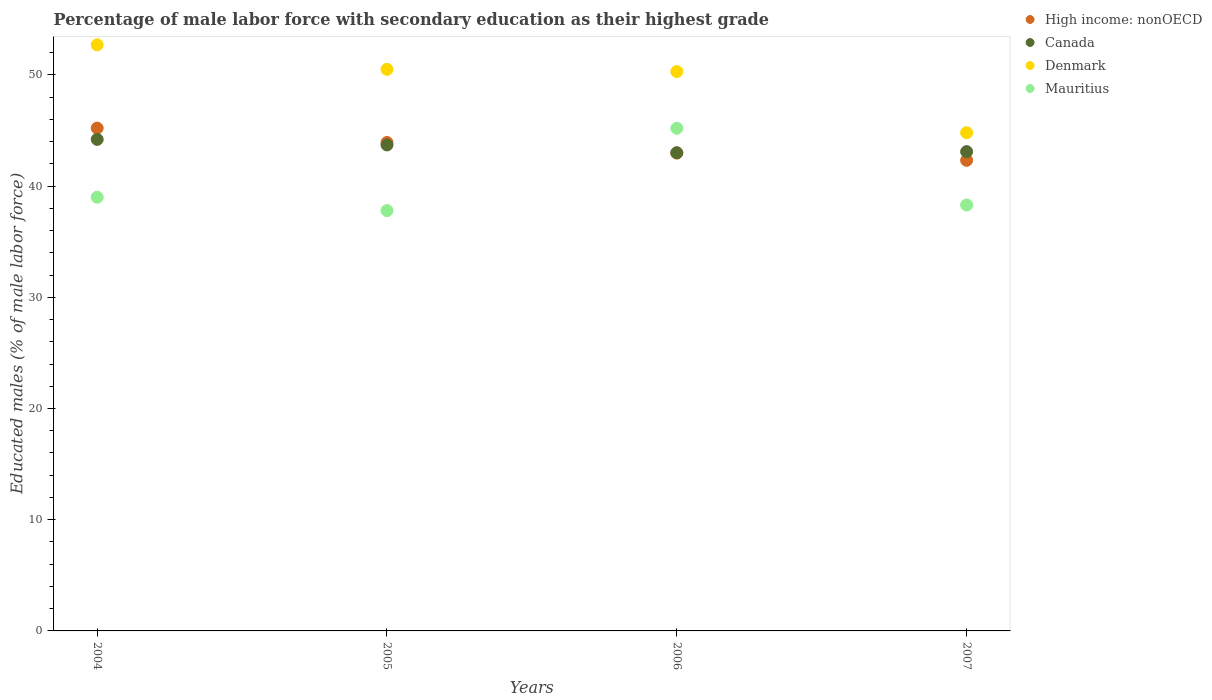Is the number of dotlines equal to the number of legend labels?
Offer a very short reply. Yes. What is the percentage of male labor force with secondary education in Denmark in 2007?
Your answer should be compact. 44.8. Across all years, what is the maximum percentage of male labor force with secondary education in High income: nonOECD?
Give a very brief answer. 45.21. Across all years, what is the minimum percentage of male labor force with secondary education in Canada?
Offer a very short reply. 43. In which year was the percentage of male labor force with secondary education in Canada maximum?
Give a very brief answer. 2004. In which year was the percentage of male labor force with secondary education in Canada minimum?
Give a very brief answer. 2006. What is the total percentage of male labor force with secondary education in Canada in the graph?
Your response must be concise. 174. What is the difference between the percentage of male labor force with secondary education in High income: nonOECD in 2004 and that in 2005?
Keep it short and to the point. 1.29. What is the difference between the percentage of male labor force with secondary education in Mauritius in 2006 and the percentage of male labor force with secondary education in High income: nonOECD in 2005?
Give a very brief answer. 1.28. What is the average percentage of male labor force with secondary education in Mauritius per year?
Make the answer very short. 40.07. In the year 2005, what is the difference between the percentage of male labor force with secondary education in High income: nonOECD and percentage of male labor force with secondary education in Mauritius?
Give a very brief answer. 6.12. What is the ratio of the percentage of male labor force with secondary education in Denmark in 2006 to that in 2007?
Provide a short and direct response. 1.12. Is the percentage of male labor force with secondary education in Canada in 2004 less than that in 2007?
Offer a terse response. No. What is the difference between the highest and the lowest percentage of male labor force with secondary education in Denmark?
Make the answer very short. 7.9. Is it the case that in every year, the sum of the percentage of male labor force with secondary education in Mauritius and percentage of male labor force with secondary education in Canada  is greater than the sum of percentage of male labor force with secondary education in High income: nonOECD and percentage of male labor force with secondary education in Denmark?
Your response must be concise. Yes. Is the percentage of male labor force with secondary education in Canada strictly greater than the percentage of male labor force with secondary education in High income: nonOECD over the years?
Ensure brevity in your answer.  No. What is the difference between two consecutive major ticks on the Y-axis?
Offer a terse response. 10. Does the graph contain grids?
Give a very brief answer. No. How many legend labels are there?
Give a very brief answer. 4. What is the title of the graph?
Make the answer very short. Percentage of male labor force with secondary education as their highest grade. What is the label or title of the X-axis?
Keep it short and to the point. Years. What is the label or title of the Y-axis?
Offer a terse response. Educated males (% of male labor force). What is the Educated males (% of male labor force) of High income: nonOECD in 2004?
Your answer should be compact. 45.21. What is the Educated males (% of male labor force) in Canada in 2004?
Your answer should be very brief. 44.2. What is the Educated males (% of male labor force) in Denmark in 2004?
Your answer should be compact. 52.7. What is the Educated males (% of male labor force) in Mauritius in 2004?
Provide a succinct answer. 39. What is the Educated males (% of male labor force) in High income: nonOECD in 2005?
Keep it short and to the point. 43.92. What is the Educated males (% of male labor force) of Canada in 2005?
Provide a succinct answer. 43.7. What is the Educated males (% of male labor force) in Denmark in 2005?
Offer a terse response. 50.5. What is the Educated males (% of male labor force) in Mauritius in 2005?
Your answer should be very brief. 37.8. What is the Educated males (% of male labor force) of High income: nonOECD in 2006?
Ensure brevity in your answer.  42.97. What is the Educated males (% of male labor force) in Canada in 2006?
Ensure brevity in your answer.  43. What is the Educated males (% of male labor force) in Denmark in 2006?
Make the answer very short. 50.3. What is the Educated males (% of male labor force) of Mauritius in 2006?
Give a very brief answer. 45.2. What is the Educated males (% of male labor force) of High income: nonOECD in 2007?
Offer a very short reply. 42.32. What is the Educated males (% of male labor force) of Canada in 2007?
Your response must be concise. 43.1. What is the Educated males (% of male labor force) of Denmark in 2007?
Your response must be concise. 44.8. What is the Educated males (% of male labor force) in Mauritius in 2007?
Keep it short and to the point. 38.3. Across all years, what is the maximum Educated males (% of male labor force) in High income: nonOECD?
Provide a succinct answer. 45.21. Across all years, what is the maximum Educated males (% of male labor force) in Canada?
Offer a very short reply. 44.2. Across all years, what is the maximum Educated males (% of male labor force) of Denmark?
Provide a succinct answer. 52.7. Across all years, what is the maximum Educated males (% of male labor force) in Mauritius?
Offer a terse response. 45.2. Across all years, what is the minimum Educated males (% of male labor force) of High income: nonOECD?
Make the answer very short. 42.32. Across all years, what is the minimum Educated males (% of male labor force) in Denmark?
Provide a succinct answer. 44.8. Across all years, what is the minimum Educated males (% of male labor force) in Mauritius?
Offer a very short reply. 37.8. What is the total Educated males (% of male labor force) of High income: nonOECD in the graph?
Your response must be concise. 174.42. What is the total Educated males (% of male labor force) in Canada in the graph?
Provide a short and direct response. 174. What is the total Educated males (% of male labor force) of Denmark in the graph?
Provide a short and direct response. 198.3. What is the total Educated males (% of male labor force) of Mauritius in the graph?
Provide a short and direct response. 160.3. What is the difference between the Educated males (% of male labor force) in High income: nonOECD in 2004 and that in 2005?
Provide a succinct answer. 1.29. What is the difference between the Educated males (% of male labor force) of Denmark in 2004 and that in 2005?
Your answer should be compact. 2.2. What is the difference between the Educated males (% of male labor force) of High income: nonOECD in 2004 and that in 2006?
Offer a very short reply. 2.24. What is the difference between the Educated males (% of male labor force) of Canada in 2004 and that in 2006?
Keep it short and to the point. 1.2. What is the difference between the Educated males (% of male labor force) of Denmark in 2004 and that in 2006?
Your response must be concise. 2.4. What is the difference between the Educated males (% of male labor force) of High income: nonOECD in 2004 and that in 2007?
Provide a short and direct response. 2.9. What is the difference between the Educated males (% of male labor force) in Canada in 2004 and that in 2007?
Give a very brief answer. 1.1. What is the difference between the Educated males (% of male labor force) in Denmark in 2004 and that in 2007?
Offer a very short reply. 7.9. What is the difference between the Educated males (% of male labor force) in Mauritius in 2004 and that in 2007?
Give a very brief answer. 0.7. What is the difference between the Educated males (% of male labor force) of High income: nonOECD in 2005 and that in 2006?
Ensure brevity in your answer.  0.95. What is the difference between the Educated males (% of male labor force) in Canada in 2005 and that in 2006?
Keep it short and to the point. 0.7. What is the difference between the Educated males (% of male labor force) of Denmark in 2005 and that in 2006?
Provide a short and direct response. 0.2. What is the difference between the Educated males (% of male labor force) of High income: nonOECD in 2005 and that in 2007?
Your response must be concise. 1.6. What is the difference between the Educated males (% of male labor force) in Canada in 2005 and that in 2007?
Provide a succinct answer. 0.6. What is the difference between the Educated males (% of male labor force) of Denmark in 2005 and that in 2007?
Give a very brief answer. 5.7. What is the difference between the Educated males (% of male labor force) of Mauritius in 2005 and that in 2007?
Keep it short and to the point. -0.5. What is the difference between the Educated males (% of male labor force) in High income: nonOECD in 2006 and that in 2007?
Your answer should be compact. 0.65. What is the difference between the Educated males (% of male labor force) in Mauritius in 2006 and that in 2007?
Make the answer very short. 6.9. What is the difference between the Educated males (% of male labor force) of High income: nonOECD in 2004 and the Educated males (% of male labor force) of Canada in 2005?
Provide a succinct answer. 1.51. What is the difference between the Educated males (% of male labor force) in High income: nonOECD in 2004 and the Educated males (% of male labor force) in Denmark in 2005?
Your answer should be very brief. -5.29. What is the difference between the Educated males (% of male labor force) in High income: nonOECD in 2004 and the Educated males (% of male labor force) in Mauritius in 2005?
Provide a short and direct response. 7.41. What is the difference between the Educated males (% of male labor force) in Canada in 2004 and the Educated males (% of male labor force) in Denmark in 2005?
Give a very brief answer. -6.3. What is the difference between the Educated males (% of male labor force) in Canada in 2004 and the Educated males (% of male labor force) in Mauritius in 2005?
Your response must be concise. 6.4. What is the difference between the Educated males (% of male labor force) in Denmark in 2004 and the Educated males (% of male labor force) in Mauritius in 2005?
Offer a terse response. 14.9. What is the difference between the Educated males (% of male labor force) of High income: nonOECD in 2004 and the Educated males (% of male labor force) of Canada in 2006?
Offer a very short reply. 2.21. What is the difference between the Educated males (% of male labor force) of High income: nonOECD in 2004 and the Educated males (% of male labor force) of Denmark in 2006?
Your answer should be compact. -5.09. What is the difference between the Educated males (% of male labor force) in High income: nonOECD in 2004 and the Educated males (% of male labor force) in Mauritius in 2006?
Your answer should be compact. 0.01. What is the difference between the Educated males (% of male labor force) of Canada in 2004 and the Educated males (% of male labor force) of Denmark in 2006?
Ensure brevity in your answer.  -6.1. What is the difference between the Educated males (% of male labor force) in High income: nonOECD in 2004 and the Educated males (% of male labor force) in Canada in 2007?
Make the answer very short. 2.11. What is the difference between the Educated males (% of male labor force) in High income: nonOECD in 2004 and the Educated males (% of male labor force) in Denmark in 2007?
Keep it short and to the point. 0.41. What is the difference between the Educated males (% of male labor force) of High income: nonOECD in 2004 and the Educated males (% of male labor force) of Mauritius in 2007?
Your response must be concise. 6.91. What is the difference between the Educated males (% of male labor force) in Canada in 2004 and the Educated males (% of male labor force) in Mauritius in 2007?
Your answer should be compact. 5.9. What is the difference between the Educated males (% of male labor force) of Denmark in 2004 and the Educated males (% of male labor force) of Mauritius in 2007?
Provide a short and direct response. 14.4. What is the difference between the Educated males (% of male labor force) of High income: nonOECD in 2005 and the Educated males (% of male labor force) of Canada in 2006?
Offer a terse response. 0.92. What is the difference between the Educated males (% of male labor force) in High income: nonOECD in 2005 and the Educated males (% of male labor force) in Denmark in 2006?
Provide a succinct answer. -6.38. What is the difference between the Educated males (% of male labor force) of High income: nonOECD in 2005 and the Educated males (% of male labor force) of Mauritius in 2006?
Your answer should be very brief. -1.28. What is the difference between the Educated males (% of male labor force) of High income: nonOECD in 2005 and the Educated males (% of male labor force) of Canada in 2007?
Your response must be concise. 0.82. What is the difference between the Educated males (% of male labor force) in High income: nonOECD in 2005 and the Educated males (% of male labor force) in Denmark in 2007?
Provide a short and direct response. -0.88. What is the difference between the Educated males (% of male labor force) in High income: nonOECD in 2005 and the Educated males (% of male labor force) in Mauritius in 2007?
Provide a short and direct response. 5.62. What is the difference between the Educated males (% of male labor force) in Canada in 2005 and the Educated males (% of male labor force) in Denmark in 2007?
Keep it short and to the point. -1.1. What is the difference between the Educated males (% of male labor force) of Canada in 2005 and the Educated males (% of male labor force) of Mauritius in 2007?
Your answer should be compact. 5.4. What is the difference between the Educated males (% of male labor force) of Denmark in 2005 and the Educated males (% of male labor force) of Mauritius in 2007?
Make the answer very short. 12.2. What is the difference between the Educated males (% of male labor force) of High income: nonOECD in 2006 and the Educated males (% of male labor force) of Canada in 2007?
Provide a short and direct response. -0.13. What is the difference between the Educated males (% of male labor force) of High income: nonOECD in 2006 and the Educated males (% of male labor force) of Denmark in 2007?
Provide a succinct answer. -1.83. What is the difference between the Educated males (% of male labor force) in High income: nonOECD in 2006 and the Educated males (% of male labor force) in Mauritius in 2007?
Give a very brief answer. 4.67. What is the difference between the Educated males (% of male labor force) of Canada in 2006 and the Educated males (% of male labor force) of Denmark in 2007?
Ensure brevity in your answer.  -1.8. What is the difference between the Educated males (% of male labor force) in Denmark in 2006 and the Educated males (% of male labor force) in Mauritius in 2007?
Your response must be concise. 12. What is the average Educated males (% of male labor force) of High income: nonOECD per year?
Your answer should be compact. 43.61. What is the average Educated males (% of male labor force) in Canada per year?
Your answer should be compact. 43.5. What is the average Educated males (% of male labor force) in Denmark per year?
Your answer should be very brief. 49.58. What is the average Educated males (% of male labor force) of Mauritius per year?
Keep it short and to the point. 40.08. In the year 2004, what is the difference between the Educated males (% of male labor force) in High income: nonOECD and Educated males (% of male labor force) in Canada?
Your answer should be very brief. 1.01. In the year 2004, what is the difference between the Educated males (% of male labor force) in High income: nonOECD and Educated males (% of male labor force) in Denmark?
Your answer should be very brief. -7.49. In the year 2004, what is the difference between the Educated males (% of male labor force) of High income: nonOECD and Educated males (% of male labor force) of Mauritius?
Offer a terse response. 6.21. In the year 2004, what is the difference between the Educated males (% of male labor force) of Denmark and Educated males (% of male labor force) of Mauritius?
Make the answer very short. 13.7. In the year 2005, what is the difference between the Educated males (% of male labor force) of High income: nonOECD and Educated males (% of male labor force) of Canada?
Offer a terse response. 0.22. In the year 2005, what is the difference between the Educated males (% of male labor force) of High income: nonOECD and Educated males (% of male labor force) of Denmark?
Your answer should be compact. -6.58. In the year 2005, what is the difference between the Educated males (% of male labor force) of High income: nonOECD and Educated males (% of male labor force) of Mauritius?
Offer a very short reply. 6.12. In the year 2005, what is the difference between the Educated males (% of male labor force) of Canada and Educated males (% of male labor force) of Denmark?
Offer a terse response. -6.8. In the year 2005, what is the difference between the Educated males (% of male labor force) in Canada and Educated males (% of male labor force) in Mauritius?
Offer a very short reply. 5.9. In the year 2005, what is the difference between the Educated males (% of male labor force) in Denmark and Educated males (% of male labor force) in Mauritius?
Make the answer very short. 12.7. In the year 2006, what is the difference between the Educated males (% of male labor force) of High income: nonOECD and Educated males (% of male labor force) of Canada?
Keep it short and to the point. -0.03. In the year 2006, what is the difference between the Educated males (% of male labor force) in High income: nonOECD and Educated males (% of male labor force) in Denmark?
Keep it short and to the point. -7.33. In the year 2006, what is the difference between the Educated males (% of male labor force) of High income: nonOECD and Educated males (% of male labor force) of Mauritius?
Ensure brevity in your answer.  -2.23. In the year 2006, what is the difference between the Educated males (% of male labor force) of Canada and Educated males (% of male labor force) of Mauritius?
Your answer should be compact. -2.2. In the year 2007, what is the difference between the Educated males (% of male labor force) in High income: nonOECD and Educated males (% of male labor force) in Canada?
Your answer should be compact. -0.78. In the year 2007, what is the difference between the Educated males (% of male labor force) of High income: nonOECD and Educated males (% of male labor force) of Denmark?
Keep it short and to the point. -2.48. In the year 2007, what is the difference between the Educated males (% of male labor force) in High income: nonOECD and Educated males (% of male labor force) in Mauritius?
Your response must be concise. 4.02. In the year 2007, what is the difference between the Educated males (% of male labor force) in Canada and Educated males (% of male labor force) in Denmark?
Ensure brevity in your answer.  -1.7. In the year 2007, what is the difference between the Educated males (% of male labor force) of Canada and Educated males (% of male labor force) of Mauritius?
Keep it short and to the point. 4.8. What is the ratio of the Educated males (% of male labor force) of High income: nonOECD in 2004 to that in 2005?
Provide a short and direct response. 1.03. What is the ratio of the Educated males (% of male labor force) of Canada in 2004 to that in 2005?
Offer a very short reply. 1.01. What is the ratio of the Educated males (% of male labor force) in Denmark in 2004 to that in 2005?
Your answer should be very brief. 1.04. What is the ratio of the Educated males (% of male labor force) in Mauritius in 2004 to that in 2005?
Ensure brevity in your answer.  1.03. What is the ratio of the Educated males (% of male labor force) of High income: nonOECD in 2004 to that in 2006?
Offer a terse response. 1.05. What is the ratio of the Educated males (% of male labor force) of Canada in 2004 to that in 2006?
Your answer should be very brief. 1.03. What is the ratio of the Educated males (% of male labor force) in Denmark in 2004 to that in 2006?
Your answer should be compact. 1.05. What is the ratio of the Educated males (% of male labor force) in Mauritius in 2004 to that in 2006?
Ensure brevity in your answer.  0.86. What is the ratio of the Educated males (% of male labor force) in High income: nonOECD in 2004 to that in 2007?
Your answer should be very brief. 1.07. What is the ratio of the Educated males (% of male labor force) of Canada in 2004 to that in 2007?
Ensure brevity in your answer.  1.03. What is the ratio of the Educated males (% of male labor force) in Denmark in 2004 to that in 2007?
Provide a succinct answer. 1.18. What is the ratio of the Educated males (% of male labor force) in Mauritius in 2004 to that in 2007?
Offer a very short reply. 1.02. What is the ratio of the Educated males (% of male labor force) of High income: nonOECD in 2005 to that in 2006?
Keep it short and to the point. 1.02. What is the ratio of the Educated males (% of male labor force) in Canada in 2005 to that in 2006?
Your answer should be very brief. 1.02. What is the ratio of the Educated males (% of male labor force) of Mauritius in 2005 to that in 2006?
Your answer should be compact. 0.84. What is the ratio of the Educated males (% of male labor force) of High income: nonOECD in 2005 to that in 2007?
Your answer should be very brief. 1.04. What is the ratio of the Educated males (% of male labor force) of Canada in 2005 to that in 2007?
Offer a very short reply. 1.01. What is the ratio of the Educated males (% of male labor force) in Denmark in 2005 to that in 2007?
Your answer should be compact. 1.13. What is the ratio of the Educated males (% of male labor force) of Mauritius in 2005 to that in 2007?
Provide a short and direct response. 0.99. What is the ratio of the Educated males (% of male labor force) of High income: nonOECD in 2006 to that in 2007?
Your answer should be compact. 1.02. What is the ratio of the Educated males (% of male labor force) of Canada in 2006 to that in 2007?
Make the answer very short. 1. What is the ratio of the Educated males (% of male labor force) in Denmark in 2006 to that in 2007?
Make the answer very short. 1.12. What is the ratio of the Educated males (% of male labor force) of Mauritius in 2006 to that in 2007?
Your answer should be very brief. 1.18. What is the difference between the highest and the second highest Educated males (% of male labor force) in High income: nonOECD?
Keep it short and to the point. 1.29. What is the difference between the highest and the second highest Educated males (% of male labor force) in Canada?
Your answer should be compact. 0.5. What is the difference between the highest and the second highest Educated males (% of male labor force) of Denmark?
Give a very brief answer. 2.2. What is the difference between the highest and the second highest Educated males (% of male labor force) of Mauritius?
Ensure brevity in your answer.  6.2. What is the difference between the highest and the lowest Educated males (% of male labor force) in High income: nonOECD?
Give a very brief answer. 2.9. What is the difference between the highest and the lowest Educated males (% of male labor force) of Canada?
Offer a terse response. 1.2. What is the difference between the highest and the lowest Educated males (% of male labor force) in Mauritius?
Your response must be concise. 7.4. 